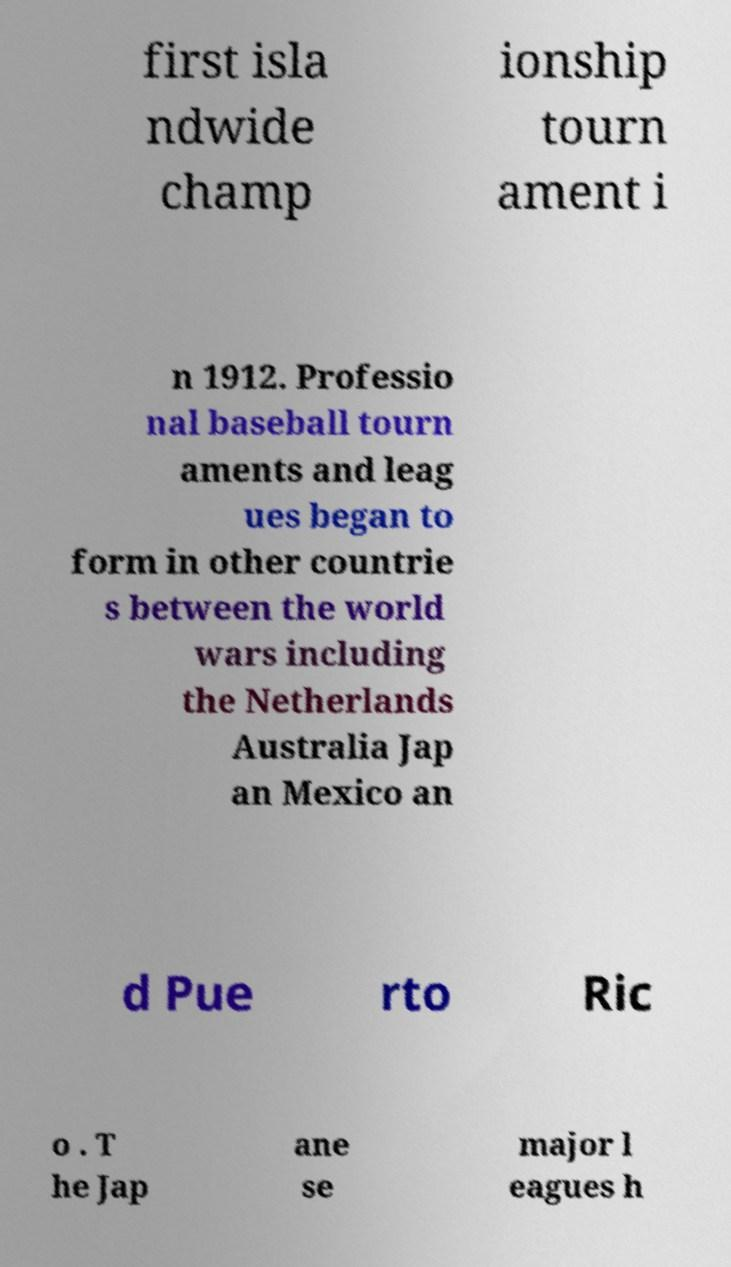Can you accurately transcribe the text from the provided image for me? first isla ndwide champ ionship tourn ament i n 1912. Professio nal baseball tourn aments and leag ues began to form in other countrie s between the world wars including the Netherlands Australia Jap an Mexico an d Pue rto Ric o . T he Jap ane se major l eagues h 